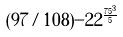Convert formula to latex. <formula><loc_0><loc_0><loc_500><loc_500>( 9 7 / 1 0 8 ) - 2 2 ^ { \frac { 7 5 ^ { 3 } } { 5 } }</formula> 